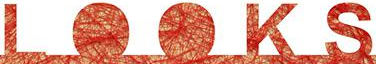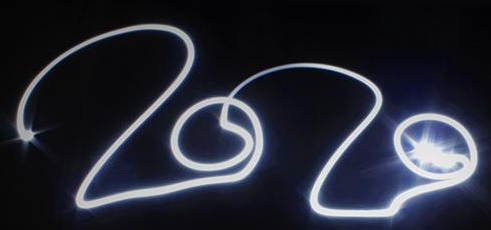Read the text from these images in sequence, separated by a semicolon. LOOKS; 2020 